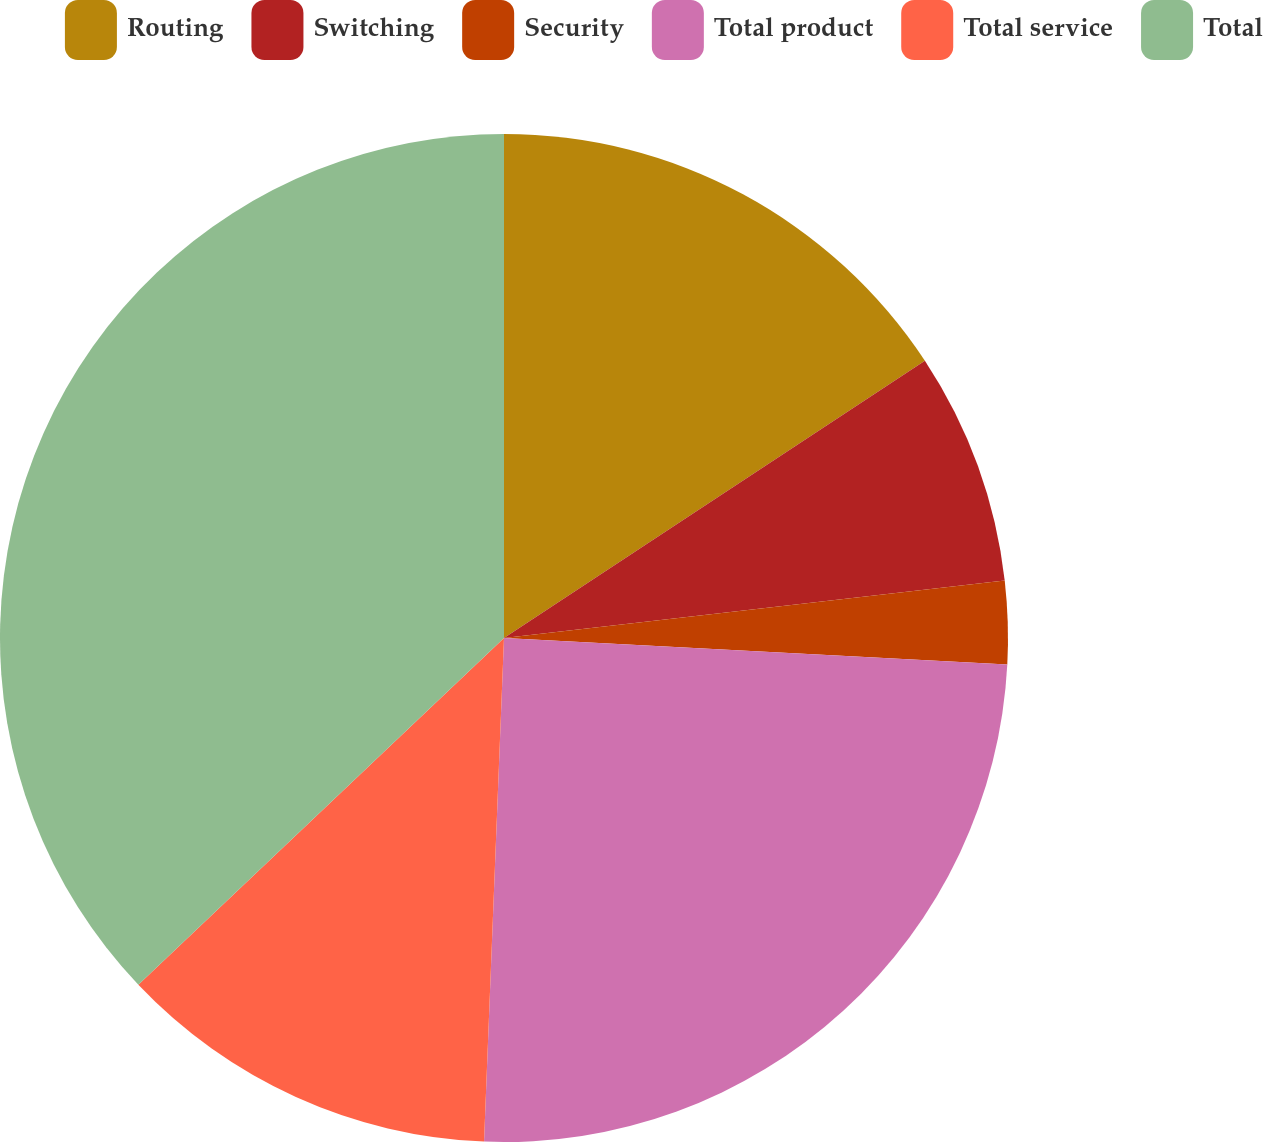<chart> <loc_0><loc_0><loc_500><loc_500><pie_chart><fcel>Routing<fcel>Switching<fcel>Security<fcel>Total product<fcel>Total service<fcel>Total<nl><fcel>15.73%<fcel>7.45%<fcel>2.66%<fcel>24.79%<fcel>12.29%<fcel>37.08%<nl></chart> 